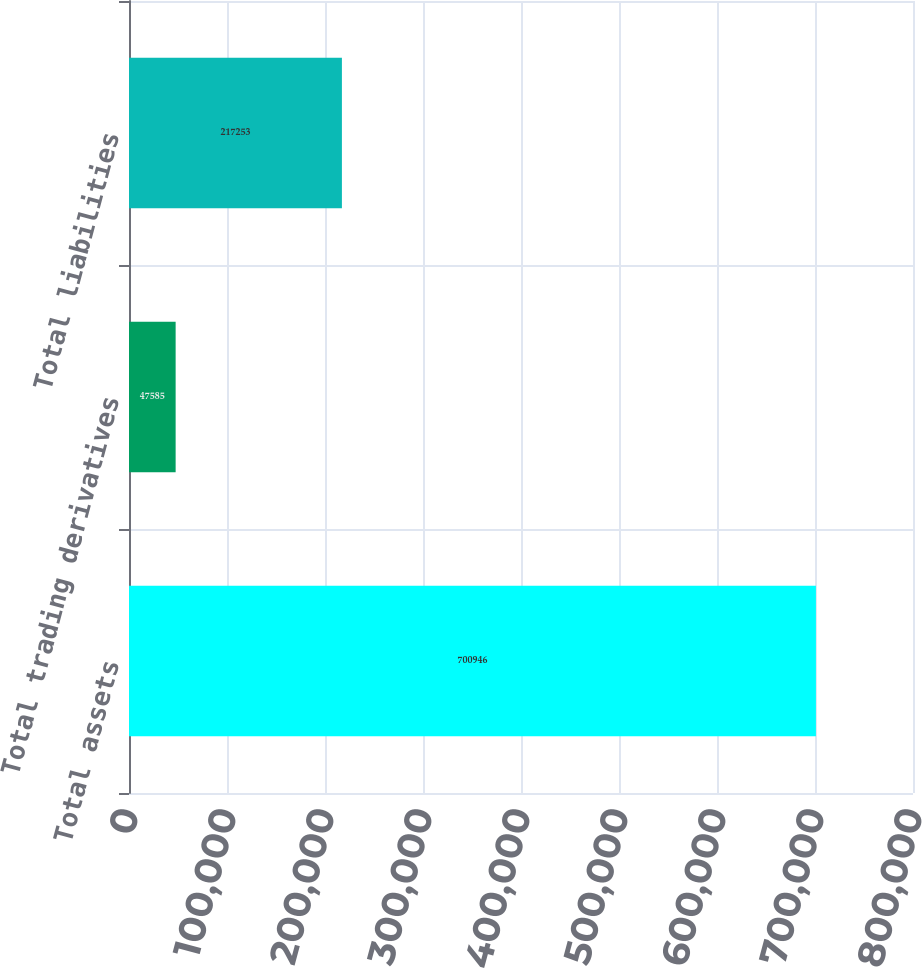Convert chart to OTSL. <chart><loc_0><loc_0><loc_500><loc_500><bar_chart><fcel>Total assets<fcel>Total trading derivatives<fcel>Total liabilities<nl><fcel>700946<fcel>47585<fcel>217253<nl></chart> 